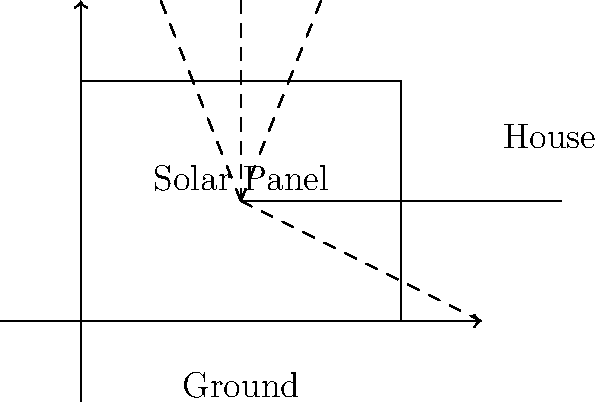A solar panel is installed near a residential area, as shown in the diagram. The panel reflects sunlight onto the ground near a house. If the angle of incidence of the sunlight on the panel is 30°, what is the angle at which the reflected light hits the ground? Assume the solar panel is perfectly flat and follows the law of reflection. To solve this problem, we need to apply the law of reflection and use our knowledge of angle relationships. Let's break it down step-by-step:

1) The law of reflection states that the angle of incidence is equal to the angle of reflection.

2) Given:
   - Angle of incidence = 30°
   - The solar panel is flat (horizontal)

3) Since the solar panel is horizontal, it forms a 90° angle with the vertical axis.

4) The angle between the incident ray and the normal (perpendicular to the surface) is 30°.

5) Therefore, the angle between the incident ray and the horizontal panel is:
   90° - 30° = 60°

6) According to the law of reflection, the reflected ray will also form a 60° angle with the panel, but on the opposite side of the normal.

7) The angle between the reflected ray and the ground is the same as the angle between the incident ray and the panel, which we calculated to be 60°.

Thus, the reflected light hits the ground at a 60° angle.

This analysis demonstrates how solar panels can potentially cause glare issues in residential areas, supporting the sceptic's concern about the impact of solar installations on surrounding areas.
Answer: 60° 